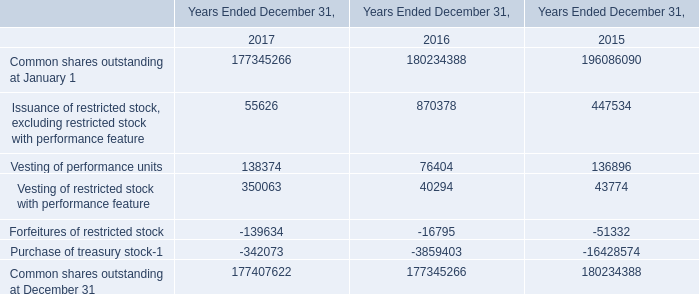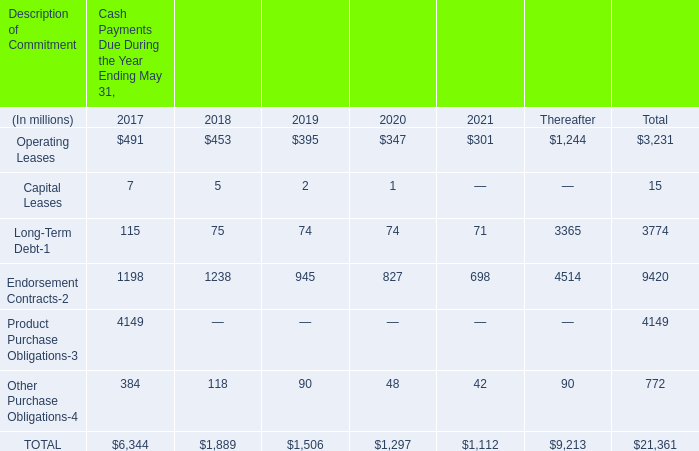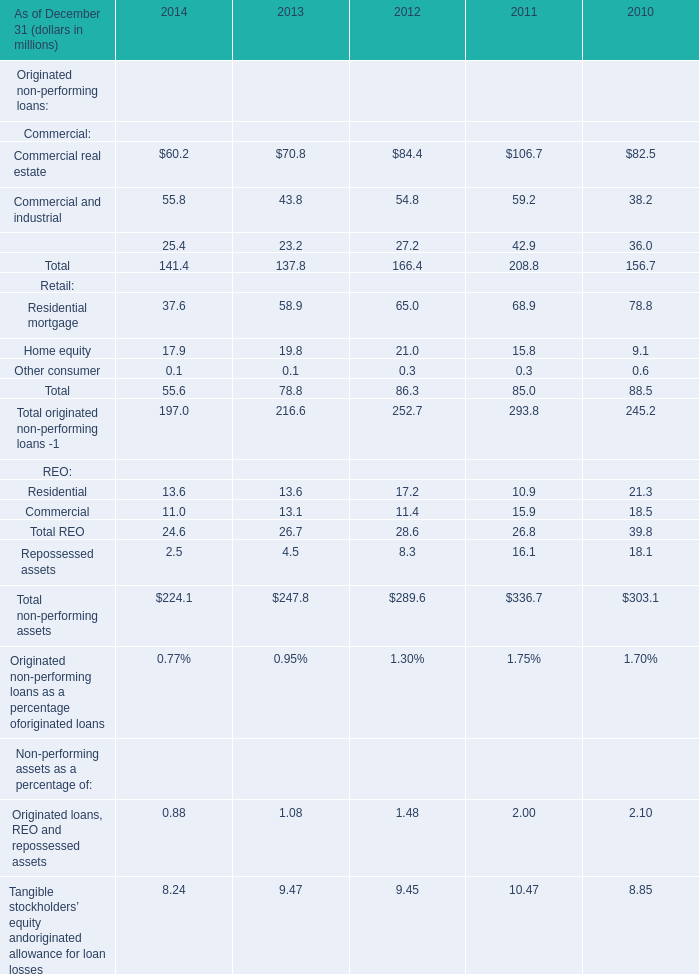What is the growing rate of Residential mortgage in the year with the most Commercial and industrial? 
Computations: ((68.9 - 78.8) / 68.9)
Answer: -0.14369. 